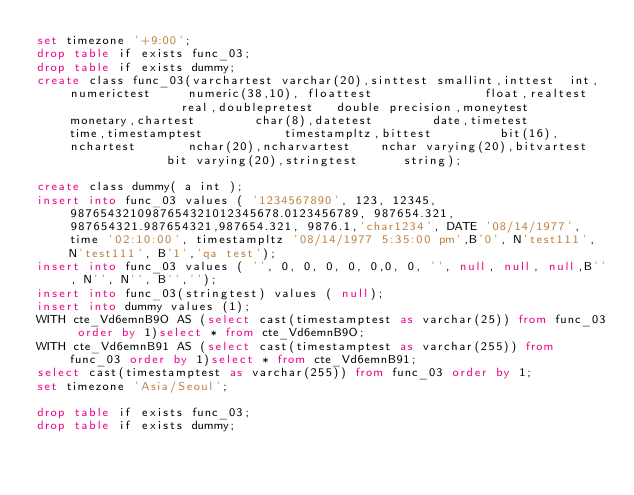<code> <loc_0><loc_0><loc_500><loc_500><_SQL_>set timezone '+9:00';
drop table if exists func_03;
drop table if exists dummy;
create class func_03(varchartest varchar(20),sinttest smallint,inttest  int, numerictest     numeric(38,10), floattest               float,realtest                real,doublepretest   double precision,moneytest       monetary,chartest        char(8),datetest        date,timetest        time,timestamptest           timestampltz,bittest         bit(16),nchartest       nchar(20),ncharvartest    nchar varying(20),bitvartest              bit varying(20),stringtest      string);

create class dummy( a int );
insert into func_03 values ( '1234567890', 123, 12345, 9876543210987654321012345678.0123456789, 987654.321, 987654321.987654321,987654.321, 9876.1,'char1234', DATE '08/14/1977', time '02:10:00', timestampltz '08/14/1977 5:35:00 pm',B'0', N'test111', N'test111', B'1','qa test');
insert into func_03 values ( '', 0, 0, 0, 0, 0,0, 0, '', null, null, null,B'', N'', N'', B'','');
insert into func_03(stringtest) values ( null);
insert into dummy values (1);
WITH cte_Vd6emnB9O AS (select cast(timestamptest as varchar(25)) from func_03 order by 1)select * from cte_Vd6emnB9O;
WITH cte_Vd6emnB91 AS (select cast(timestamptest as varchar(255)) from func_03 order by 1)select * from cte_Vd6emnB91;
select cast(timestamptest as varchar(255)) from func_03 order by 1;
set timezone 'Asia/Seoul';

drop table if exists func_03;
drop table if exists dummy;
</code> 